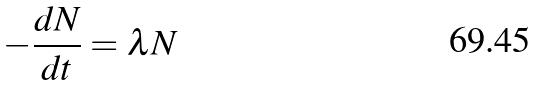Convert formula to latex. <formula><loc_0><loc_0><loc_500><loc_500>- \frac { d N } { d t } = \lambda N</formula> 